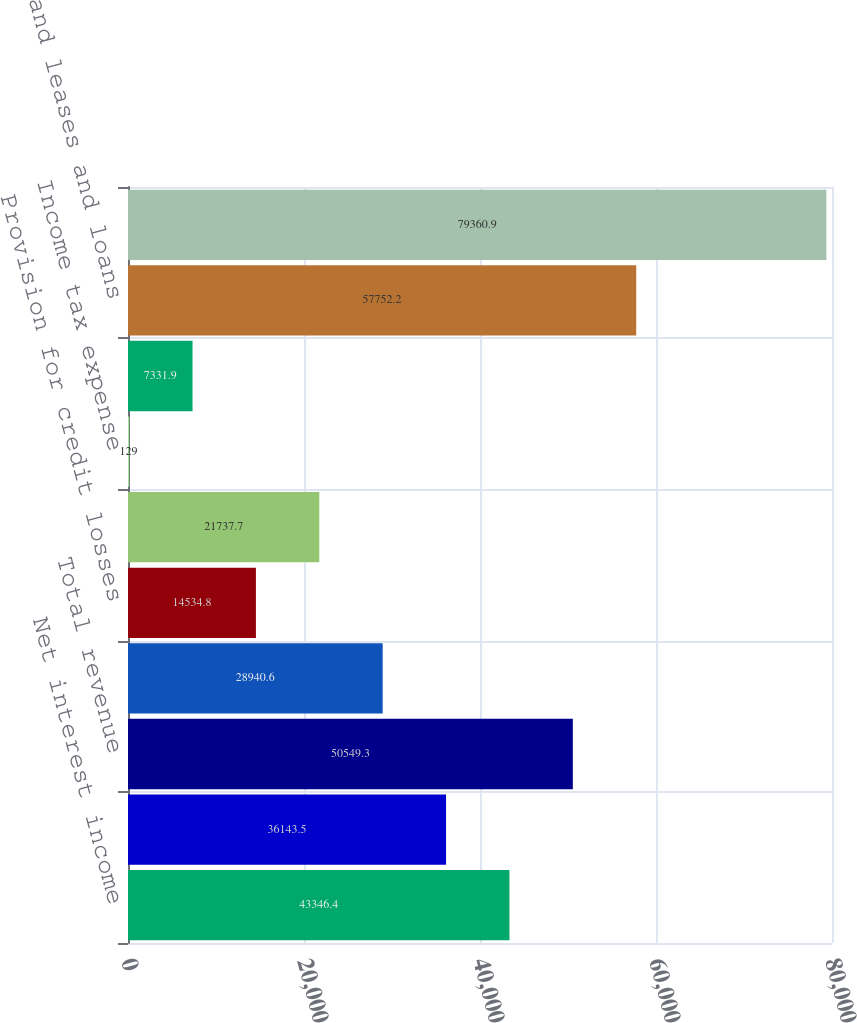<chart> <loc_0><loc_0><loc_500><loc_500><bar_chart><fcel>Net interest income<fcel>Noninterest income<fcel>Total revenue<fcel>Profit before provision for<fcel>Provision for credit losses<fcel>Income before income tax<fcel>Income tax expense<fcel>Net income<fcel>Loans and leases and loans<fcel>Total assets<nl><fcel>43346.4<fcel>36143.5<fcel>50549.3<fcel>28940.6<fcel>14534.8<fcel>21737.7<fcel>129<fcel>7331.9<fcel>57752.2<fcel>79360.9<nl></chart> 